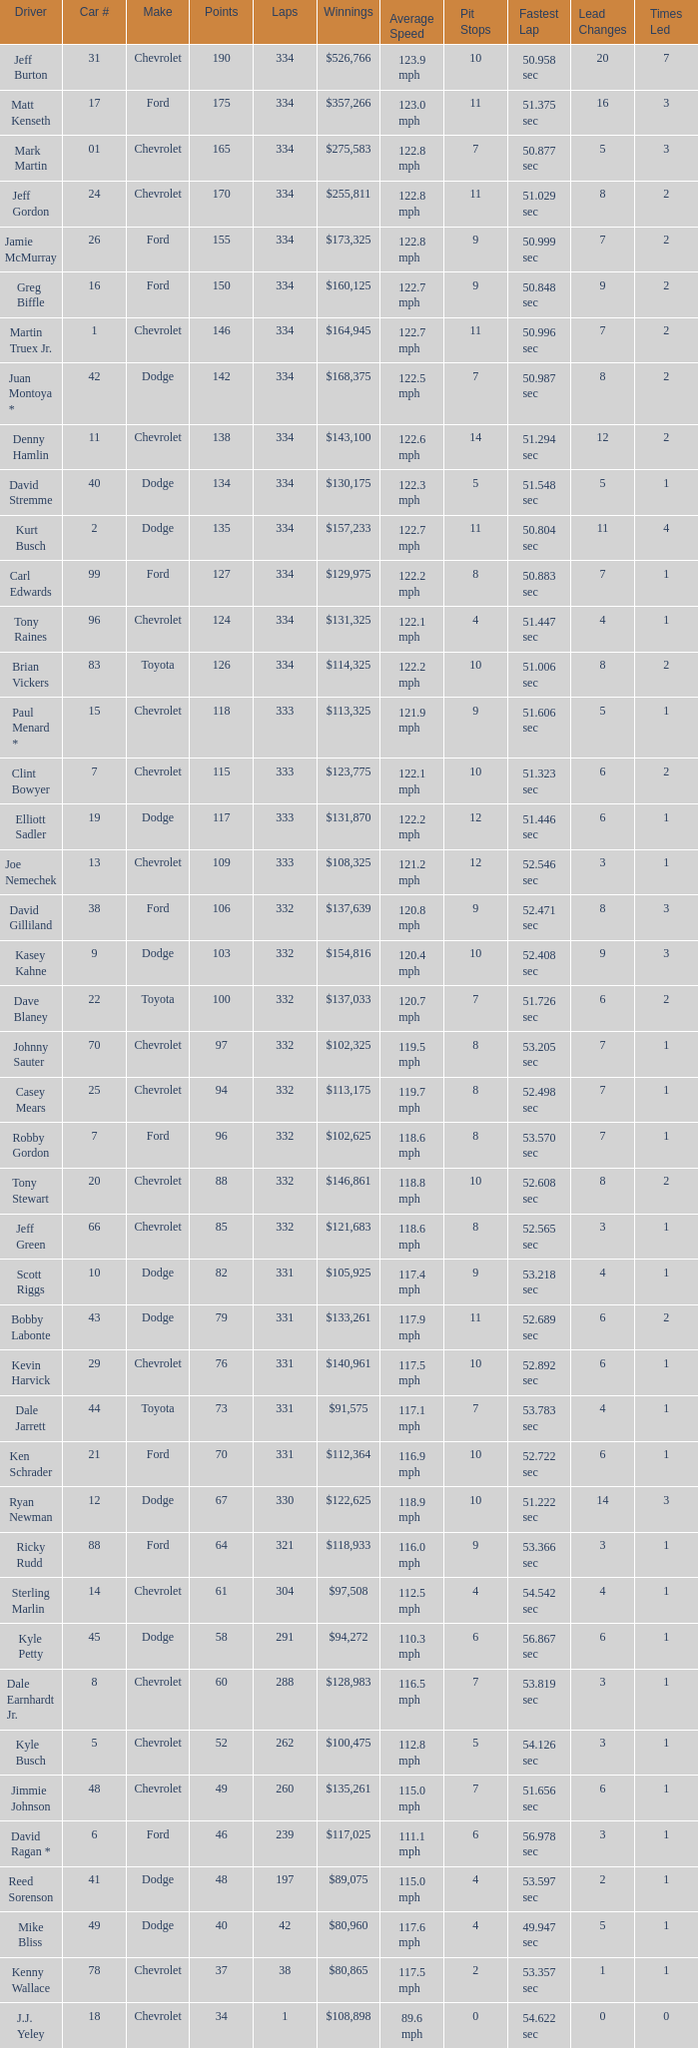Could you parse the entire table? {'header': ['Driver', 'Car #', 'Make', 'Points', 'Laps', 'Winnings', 'Average Speed', 'Pit Stops', 'Fastest Lap', 'Lead Changes', 'Times Led'], 'rows': [['Jeff Burton', '31', 'Chevrolet', '190', '334', '$526,766', '123.9 mph', '10', '50.958 sec', '20', '7'], ['Matt Kenseth', '17', 'Ford', '175', '334', '$357,266', '123.0 mph', '11', '51.375 sec', '16', '3'], ['Mark Martin', '01', 'Chevrolet', '165', '334', '$275,583', '122.8 mph', '7', '50.877 sec', '5', '3'], ['Jeff Gordon', '24', 'Chevrolet', '170', '334', '$255,811', '122.8 mph', '11', '51.029 sec', '8', '2'], ['Jamie McMurray', '26', 'Ford', '155', '334', '$173,325', '122.8 mph', '9', '50.999 sec', '7', '2'], ['Greg Biffle', '16', 'Ford', '150', '334', '$160,125', '122.7 mph', '9', '50.848 sec', '9', '2'], ['Martin Truex Jr.', '1', 'Chevrolet', '146', '334', '$164,945', '122.7 mph', '11', '50.996 sec', '7', '2'], ['Juan Montoya *', '42', 'Dodge', '142', '334', '$168,375', '122.5 mph', '7', '50.987 sec', '8', '2'], ['Denny Hamlin', '11', 'Chevrolet', '138', '334', '$143,100', '122.6 mph', '14', '51.294 sec', '12', '2'], ['David Stremme', '40', 'Dodge', '134', '334', '$130,175', '122.3 mph', '5', '51.548 sec', '5', '1'], ['Kurt Busch', '2', 'Dodge', '135', '334', '$157,233', '122.7 mph', '11', '50.804 sec', '11', '4'], ['Carl Edwards', '99', 'Ford', '127', '334', '$129,975', '122.2 mph', '8', '50.883 sec', '7', '1'], ['Tony Raines', '96', 'Chevrolet', '124', '334', '$131,325', '122.1 mph', '4', '51.447 sec', '4', '1'], ['Brian Vickers', '83', 'Toyota', '126', '334', '$114,325', '122.2 mph', '10', '51.006 sec', '8', '2'], ['Paul Menard *', '15', 'Chevrolet', '118', '333', '$113,325', '121.9 mph', '9', '51.606 sec', '5', '1'], ['Clint Bowyer', '7', 'Chevrolet', '115', '333', '$123,775', '122.1 mph', '10', '51.323 sec', '6', '2'], ['Elliott Sadler', '19', 'Dodge', '117', '333', '$131,870', '122.2 mph', '12', '51.446 sec', '6', '1'], ['Joe Nemechek', '13', 'Chevrolet', '109', '333', '$108,325', '121.2 mph', '12', '52.546 sec', '3', '1'], ['David Gilliland', '38', 'Ford', '106', '332', '$137,639', '120.8 mph', '9', '52.471 sec', '8', '3'], ['Kasey Kahne', '9', 'Dodge', '103', '332', '$154,816', '120.4 mph', '10', '52.408 sec', '9', '3'], ['Dave Blaney', '22', 'Toyota', '100', '332', '$137,033', '120.7 mph', '7', '51.726 sec', '6', '2'], ['Johnny Sauter', '70', 'Chevrolet', '97', '332', '$102,325', '119.5 mph', '8', '53.205 sec', '7', '1'], ['Casey Mears', '25', 'Chevrolet', '94', '332', '$113,175', '119.7 mph', '8', '52.498 sec', '7', '1'], ['Robby Gordon', '7', 'Ford', '96', '332', '$102,625', '118.6 mph', '8', '53.570 sec', '7', '1'], ['Tony Stewart', '20', 'Chevrolet', '88', '332', '$146,861', '118.8 mph', '10', '52.608 sec', '8', '2'], ['Jeff Green', '66', 'Chevrolet', '85', '332', '$121,683', '118.6 mph', '8', '52.565 sec', '3', '1'], ['Scott Riggs', '10', 'Dodge', '82', '331', '$105,925', '117.4 mph', '9', '53.218 sec', '4', '1'], ['Bobby Labonte', '43', 'Dodge', '79', '331', '$133,261', '117.9 mph', '11', '52.689 sec', '6', '2'], ['Kevin Harvick', '29', 'Chevrolet', '76', '331', '$140,961', '117.5 mph', '10', '52.892 sec', '6', '1'], ['Dale Jarrett', '44', 'Toyota', '73', '331', '$91,575', '117.1 mph', '7', '53.783 sec', '4', '1'], ['Ken Schrader', '21', 'Ford', '70', '331', '$112,364', '116.9 mph', '10', '52.722 sec', '6', '1'], ['Ryan Newman', '12', 'Dodge', '67', '330', '$122,625', '118.9 mph', '10', '51.222 sec', '14', '3'], ['Ricky Rudd', '88', 'Ford', '64', '321', '$118,933', '116.0 mph', '9', '53.366 sec', '3', '1'], ['Sterling Marlin', '14', 'Chevrolet', '61', '304', '$97,508', '112.5 mph', '4', '54.542 sec', '4', '1'], ['Kyle Petty', '45', 'Dodge', '58', '291', '$94,272', '110.3 mph', '6', '56.867 sec', '6', '1'], ['Dale Earnhardt Jr.', '8', 'Chevrolet', '60', '288', '$128,983', '116.5 mph', '7', '53.819 sec', '3', '1'], ['Kyle Busch', '5', 'Chevrolet', '52', '262', '$100,475', '112.8 mph', '5', '54.126 sec', '3', '1'], ['Jimmie Johnson', '48', 'Chevrolet', '49', '260', '$135,261', '115.0 mph', '7', '51.656 sec', '6', '1'], ['David Ragan *', '6', 'Ford', '46', '239', '$117,025', '111.1 mph', '6', '56.978 sec', '3', '1'], ['Reed Sorenson', '41', 'Dodge', '48', '197', '$89,075', '115.0 mph', '4', '53.597 sec', '2', '1'], ['Mike Bliss', '49', 'Dodge', '40', '42', '$80,960', '117.6 mph', '4', '49.947 sec', '5', '1'], ['Kenny Wallace', '78', 'Chevrolet', '37', '38', '$80,865', '117.5 mph', '2', '53.357 sec', '1', '1'], ['J.J. Yeley', '18', 'Chevrolet', '34', '1', '$108,898', '89.6 mph', '0', '54.622 sec', '0', '0']]} How many total laps did the Chevrolet that won $97,508 make? 1.0. 